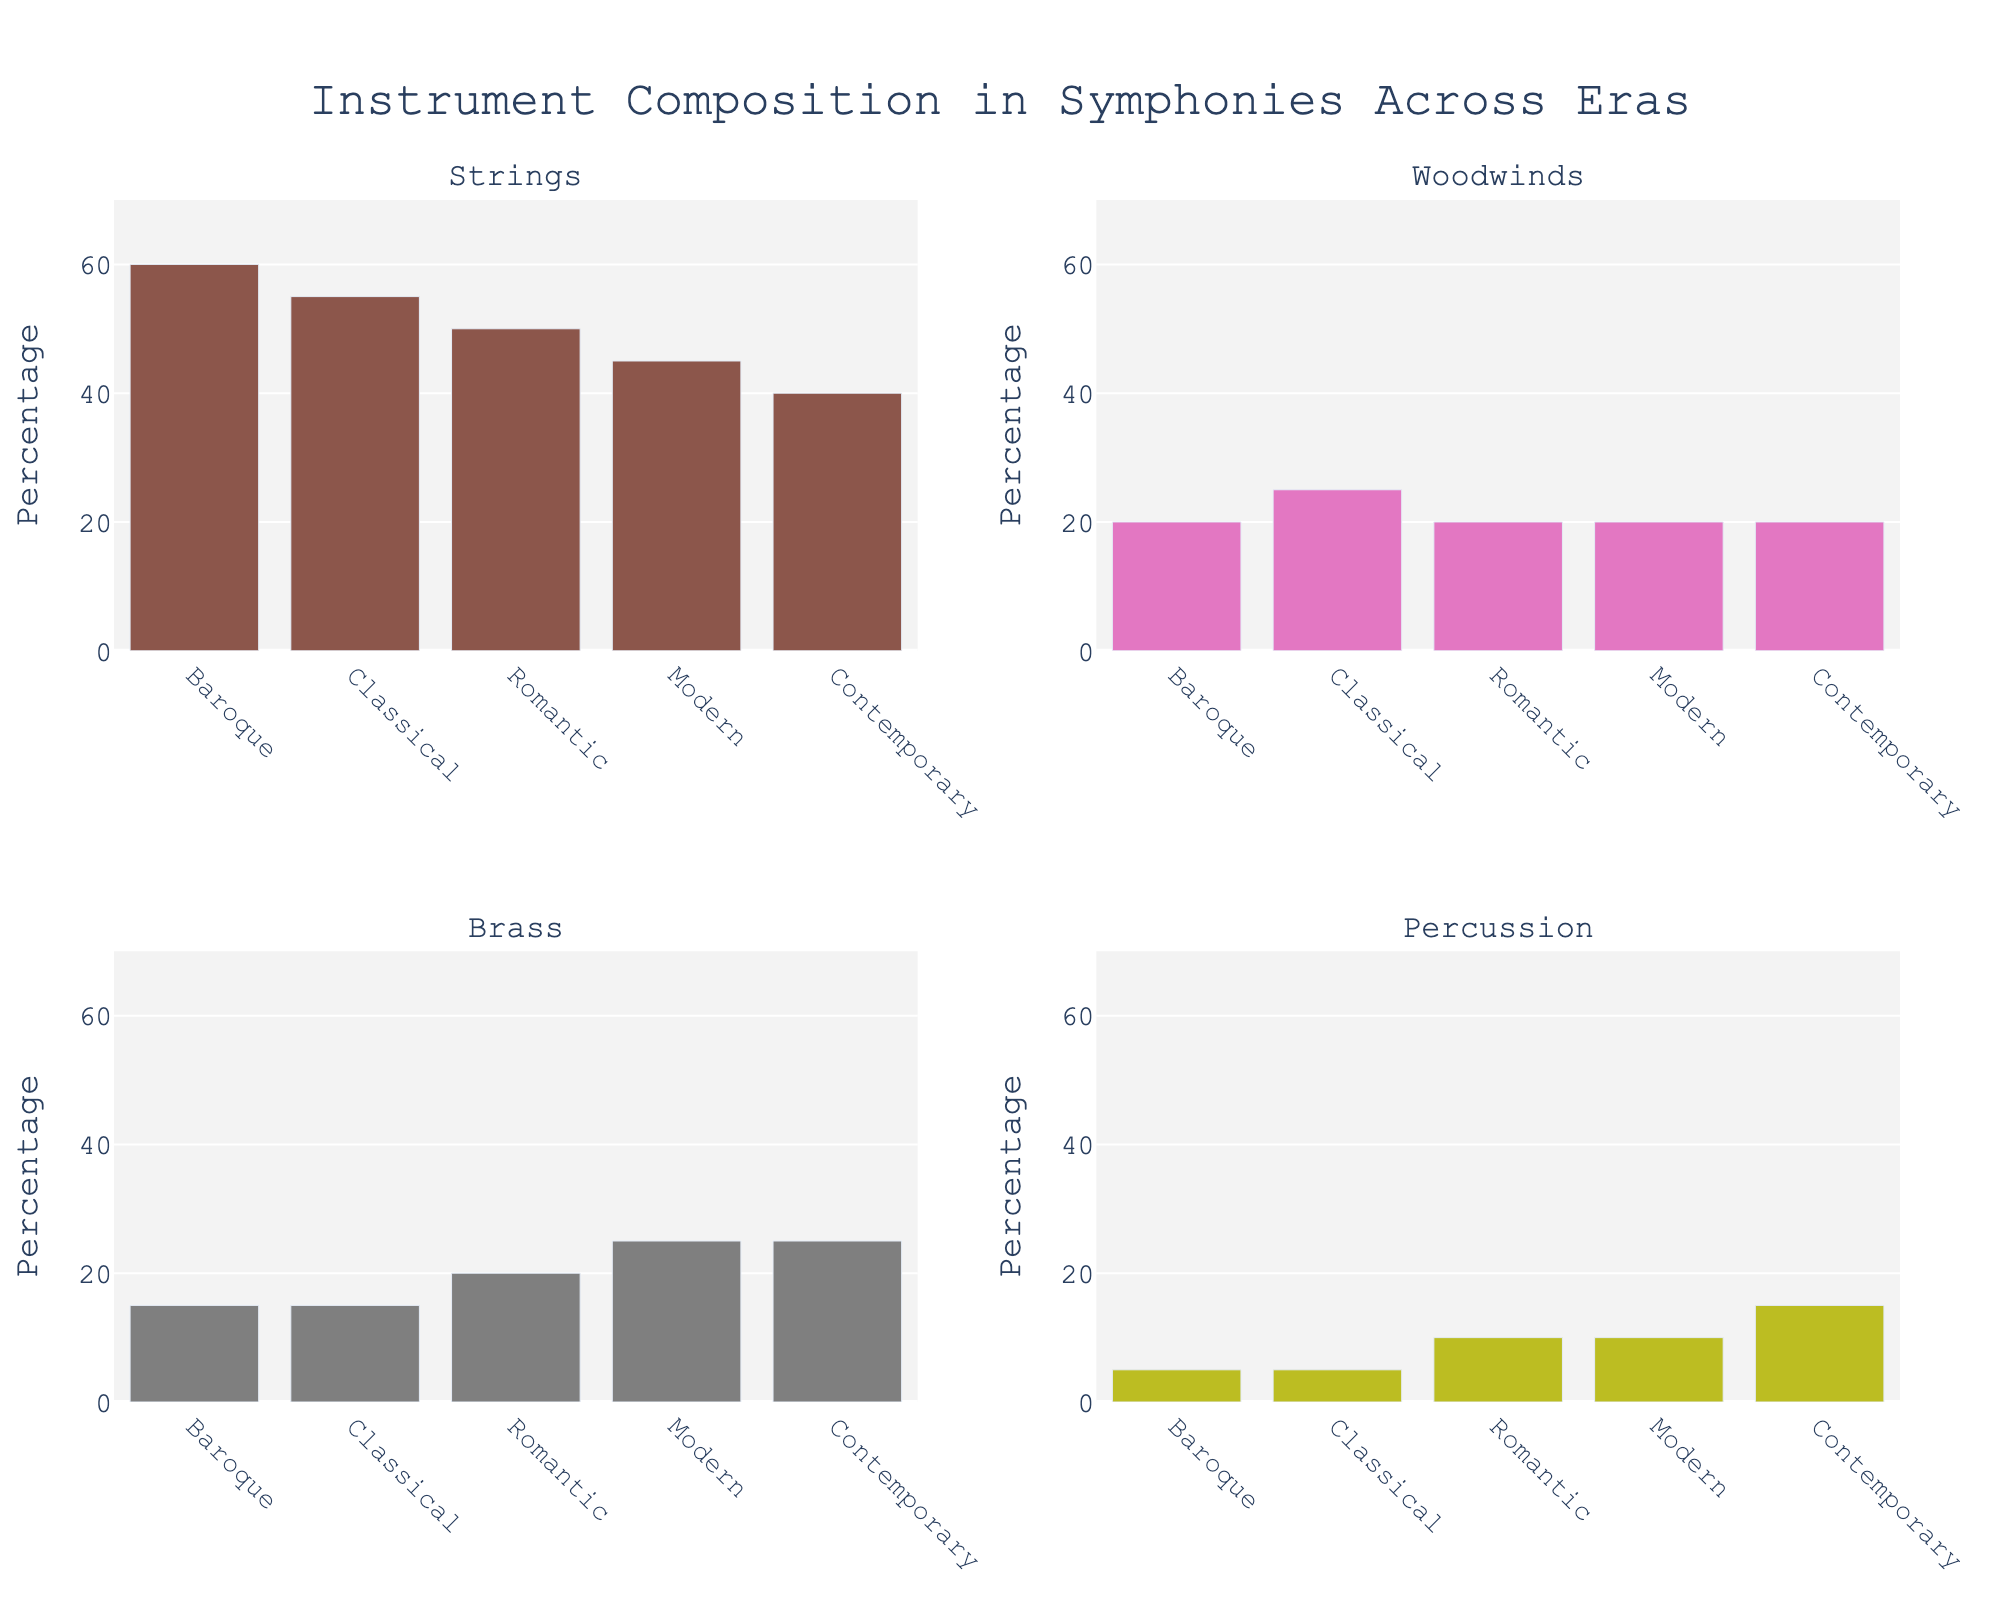What's the title of the figure? The title is usually displayed at the top of the figure. The figure's title here is "Instrument Composition in Symphonies Across Eras".
Answer: Instrument Composition in Symphonies Across Eras What's the dominant instrument in the Baroque era? By looking at the subplots, the Strings have the highest percentage in the Baroque era.
Answer: Strings How do the percentage of Strings change from Baroque to Contemporary era? Baroque has 60%, and Contemporary has 40%. The change is 60% - 40% = 20%.
Answer: 20% Which era has the highest percentage of Percussion? By checking all subplots in the Percussion column, the Contemporary era has the highest percentage with 15%.
Answer: Contemporary Compare the Brass instrument percentages between the Romantic and Modern eras. The subplot for Brass shows that the Romantic era has 20%, while the Modern era has 25%. So, Modern is higher.
Answer: Modern What's the average percentage of Woodwinds across all eras? Add the percentages of Woodwinds for all eras: 20 + 25 + 20 + 20 + 20 = 105. Then, divide by the number of eras (5). 105 / 5 = 21%.
Answer: 21% Which instrument's percentage remains the most consistent across all eras? Percussion has mostly increased while remaining relatively low. All other instruments have more significant changes.
Answer: Woodwinds In which era did Strings have the smallest percentage? The subplot for Strings shows that the Contemporary era has the smallest percentage of 40%.
Answer: Contemporary Summarize the trend for Brass instruments from Baroque to Contemporary eras. Start with Baroque 15%, then Classical also has 15%, Romantic increases to 20%, Modern to 25%, and Contemporary stays at 25%. This indicates a general increasing trend.
Answer: Increasing What is the combined percentage for Woodwinds and Percussion in the Classical era? In the Classical era, Woodwinds are 25% and Percussion 5%. The combined percentage is 25% + 5% = 30%.
Answer: 30% 